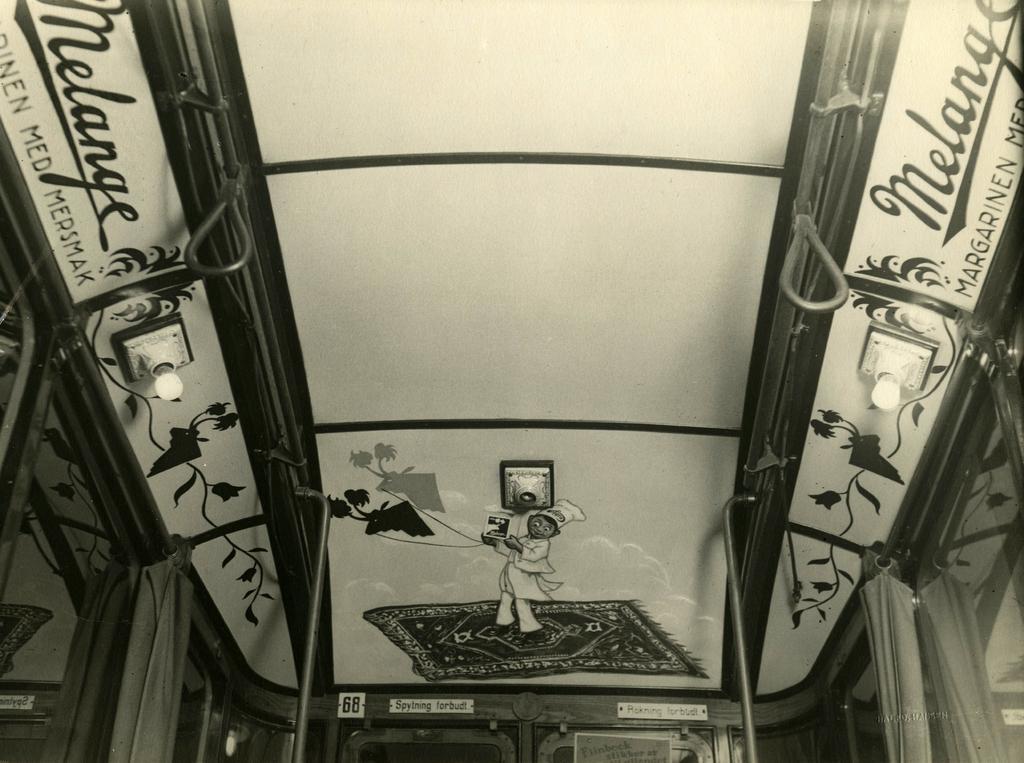Could you give a brief overview of what you see in this image? There are paintings of a person, plants and texts and there are lights attached to the roof. Below them, there are glass windows and there are curtains. 